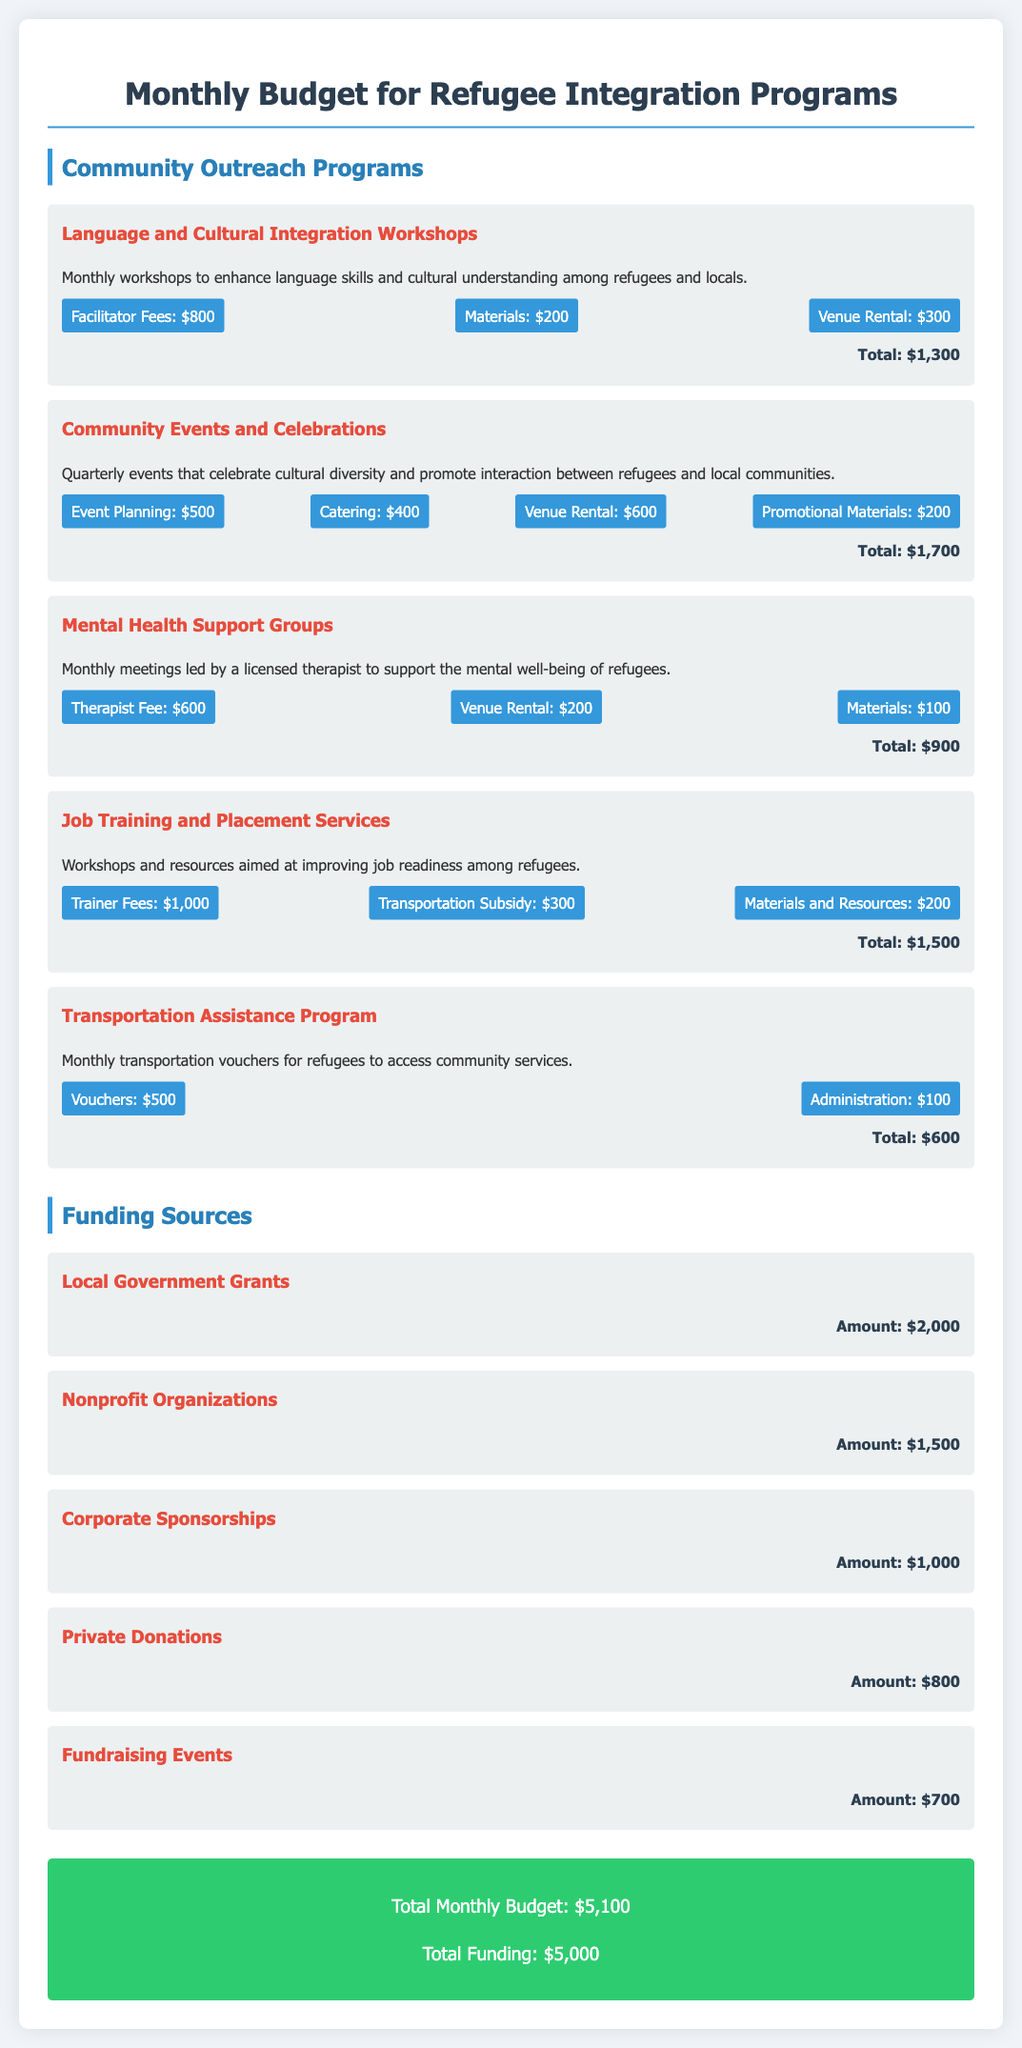What is the total cost for Language and Cultural Integration Workshops? The total cost for the workshops is specifically listed in the document, which is $1,300.
Answer: $1,300 How many programs are listed under Community Outreach Programs? The document details five distinct programs under the outreach section, indicating the initiatives for social integration.
Answer: Five What is the funding source from Private Donations? The document provides a specific amount for Private Donations, which is $800.
Answer: $800 What is the total monthly budget? The total monthly budget is summarized clearly at the end of the document, totaling $5,100.
Answer: $5,100 Which program requires the highest funding? Upon analyzing the costs of each program, Job Training and Placement Services require the most funding at $1,500.
Answer: Job Training and Placement Services What is the total amount from Funding Sources? The document sums up the amounts from various funding sources, leading to a total of $5,000.
Answer: $5,000 Which program is related to mental well-being? The program explicitly mentioned for mental support is Mental Health Support Groups, focusing on the well-being of refugees.
Answer: Mental Health Support Groups Which funding source has the least amount? The document indicates that Fundraising Events is the least contributing funding source with an amount of $700.
Answer: Fundraising Events 